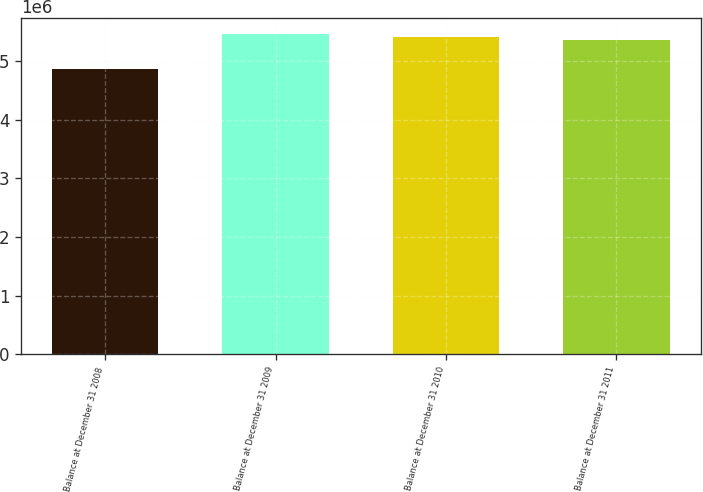Convert chart. <chart><loc_0><loc_0><loc_500><loc_500><bar_chart><fcel>Balance at December 31 2008<fcel>Balance at December 31 2009<fcel>Balance at December 31 2010<fcel>Balance at December 31 2011<nl><fcel>4.8693e+06<fcel>5.46083e+06<fcel>5.41076e+06<fcel>5.36068e+06<nl></chart> 